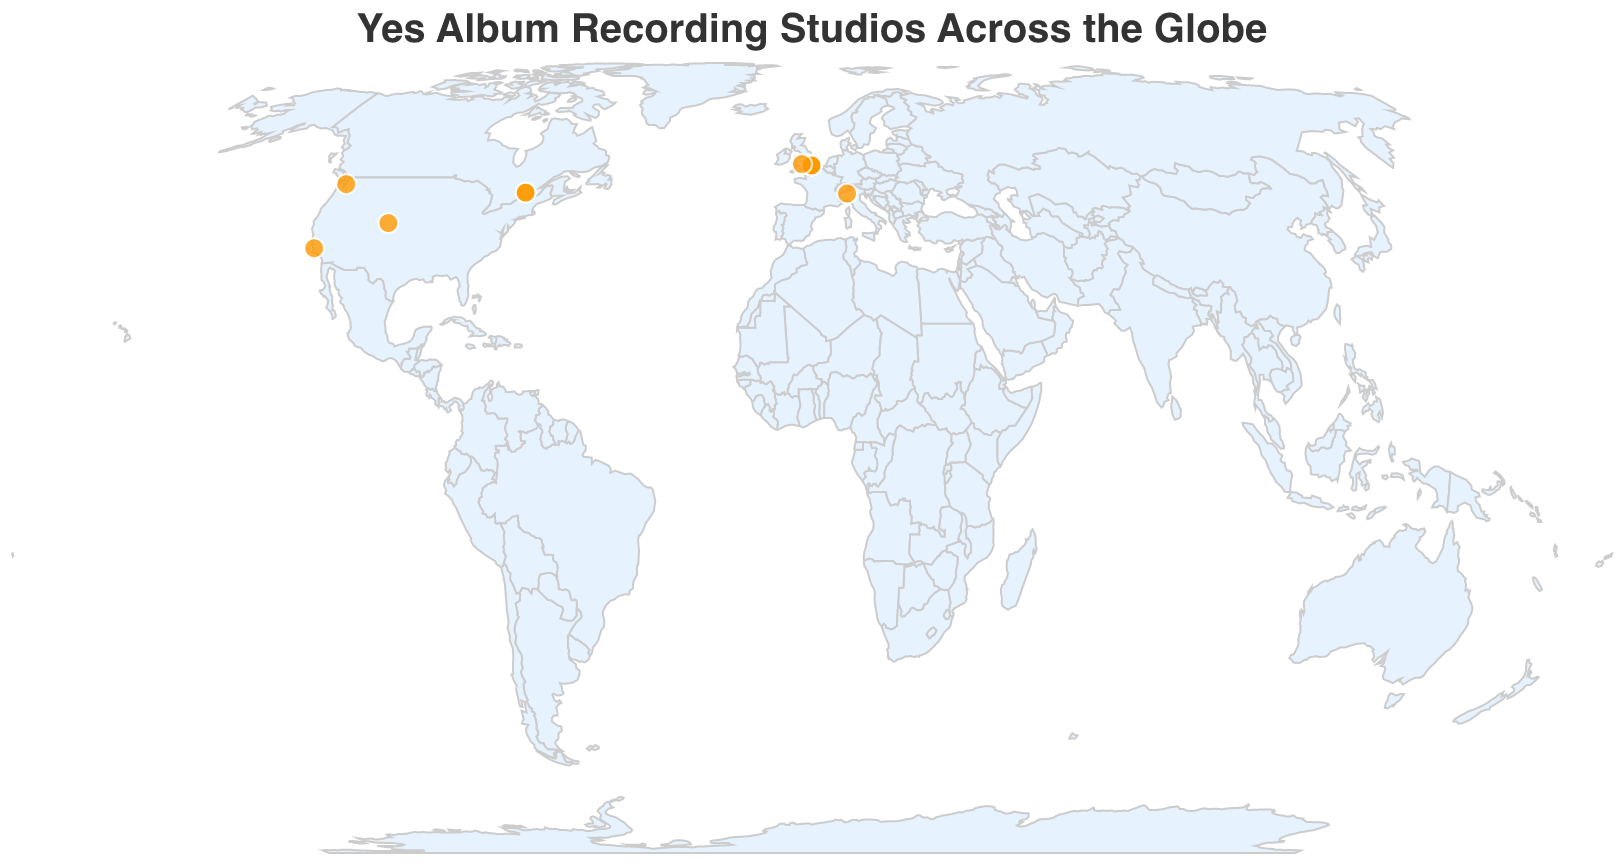Which cities in the UK were used as recording locations for Yes albums? The figure shows that the cities in the UK used for recording Yes albums are London and Monmouth.
Answer: London, Monmouth How many studios did Yes use in London over their career, according to the plot? The data points in London indicate four different studios: Advision Studios, Trident Studios, Morgan Studios, and SARM East Studios.
Answer: Four What album was recorded at Caribou Ranch in the USA? By examining the tooltip information for the Caribou Ranch point in the USA on the map, we see that the album recorded there is "Going for the One."
Answer: Going for the One Which country has the most recording studios used by Yes? The data points and tooltips reveal that the UK has the most recording studios used by Yes: Advision Studios, Trident Studios, Morgan Studios, SARM East Studios, and Benifold Studios.
Answer: UK Compare the number of albums recorded in the UK versus the USA. Which is larger? The figure shows that there are five albums recorded in the UK (The Yes Album, Fragile, Close to the Edge, Tales from Topographic Oceans, Drama, Fly from Here), and three albums recorded in the USA (Going for the One, The Ladder, Magnification). Hence, the number of albums recorded in the UK is larger.
Answer: UK Which recording studio outside of the UK and USA was used for the album "Big Generator"? By exploring the tooltip information, we find that "Big Generator" was recorded at Lark Recording Studios in Carimate, Italy.
Answer: Lark Recording Studios in Carimate, Italy Identify the albums recorded in Canada. The map shows two recording studios in Morin-Heights, Canada: Morin Heights Studio and Le Studio. The albums recorded there are Tormato and 90125.
Answer: Tormato, 90125 What is the northernmost studio used by Yes, and which album was recorded there? The map indicates that the northernmost recording studio is in Morin-Heights, Canada (Le Studio and Morin Heights Studio), where the albums Tormato and 90125 were recorded.
Answer: Morin-Heights Studio, 90125 Between the albums "Fragile" and "Magnification," which was recorded further west? According to the plot, "Fragile" was recorded in London, UK (longitude: -0.1390), and "Magnification" was recorded in Seattle, USA (longitude: -122.3321). Because -122.3321 is further west on the longitude scale than -0.1390, "Magnification" was recorded further west.
Answer: Magnification 